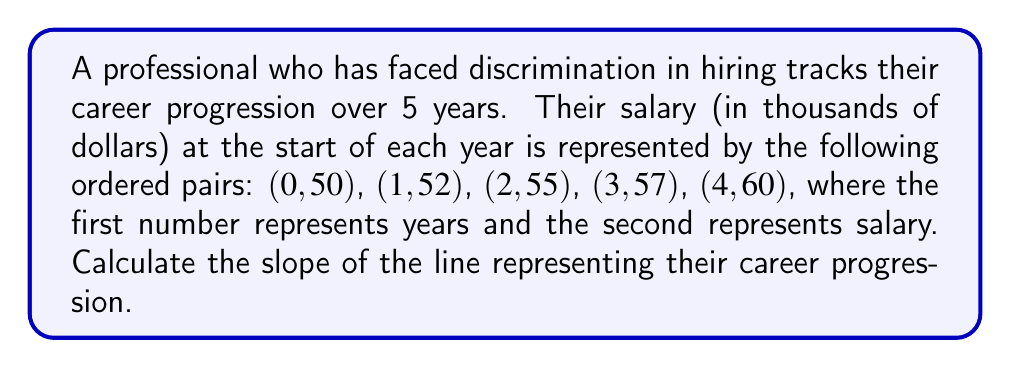Provide a solution to this math problem. To calculate the slope of a line representing career progression, we'll use the slope formula:

$$ m = \frac{y_2 - y_1}{x_2 - x_1} $$

Where $(x_1, y_1)$ and $(x_2, y_2)$ are two points on the line.

Let's use the first and last points: (0, 50) and (4, 60)

$x_1 = 0$, $y_1 = 50$
$x_2 = 4$, $y_2 = 60$

Substituting into the formula:

$$ m = \frac{60 - 50}{4 - 0} = \frac{10}{4} = 2.5 $$

The slope represents the rate of change in salary per year. In this case, it's an increase of $2,500 per year.

To verify, we can check if this slope applies to other points:
(1, 52): $50 + 2.5(1) = 52.5$ (close to 52)
(2, 55): $50 + 2.5(2) = 55$ (exact)
(3, 57): $50 + 2.5(3) = 57.5$ (close to 57)

The slight variations are due to rounding and potential non-linear progression, but the overall trend is represented by the calculated slope.
Answer: $2.5$ thousand dollars per year 